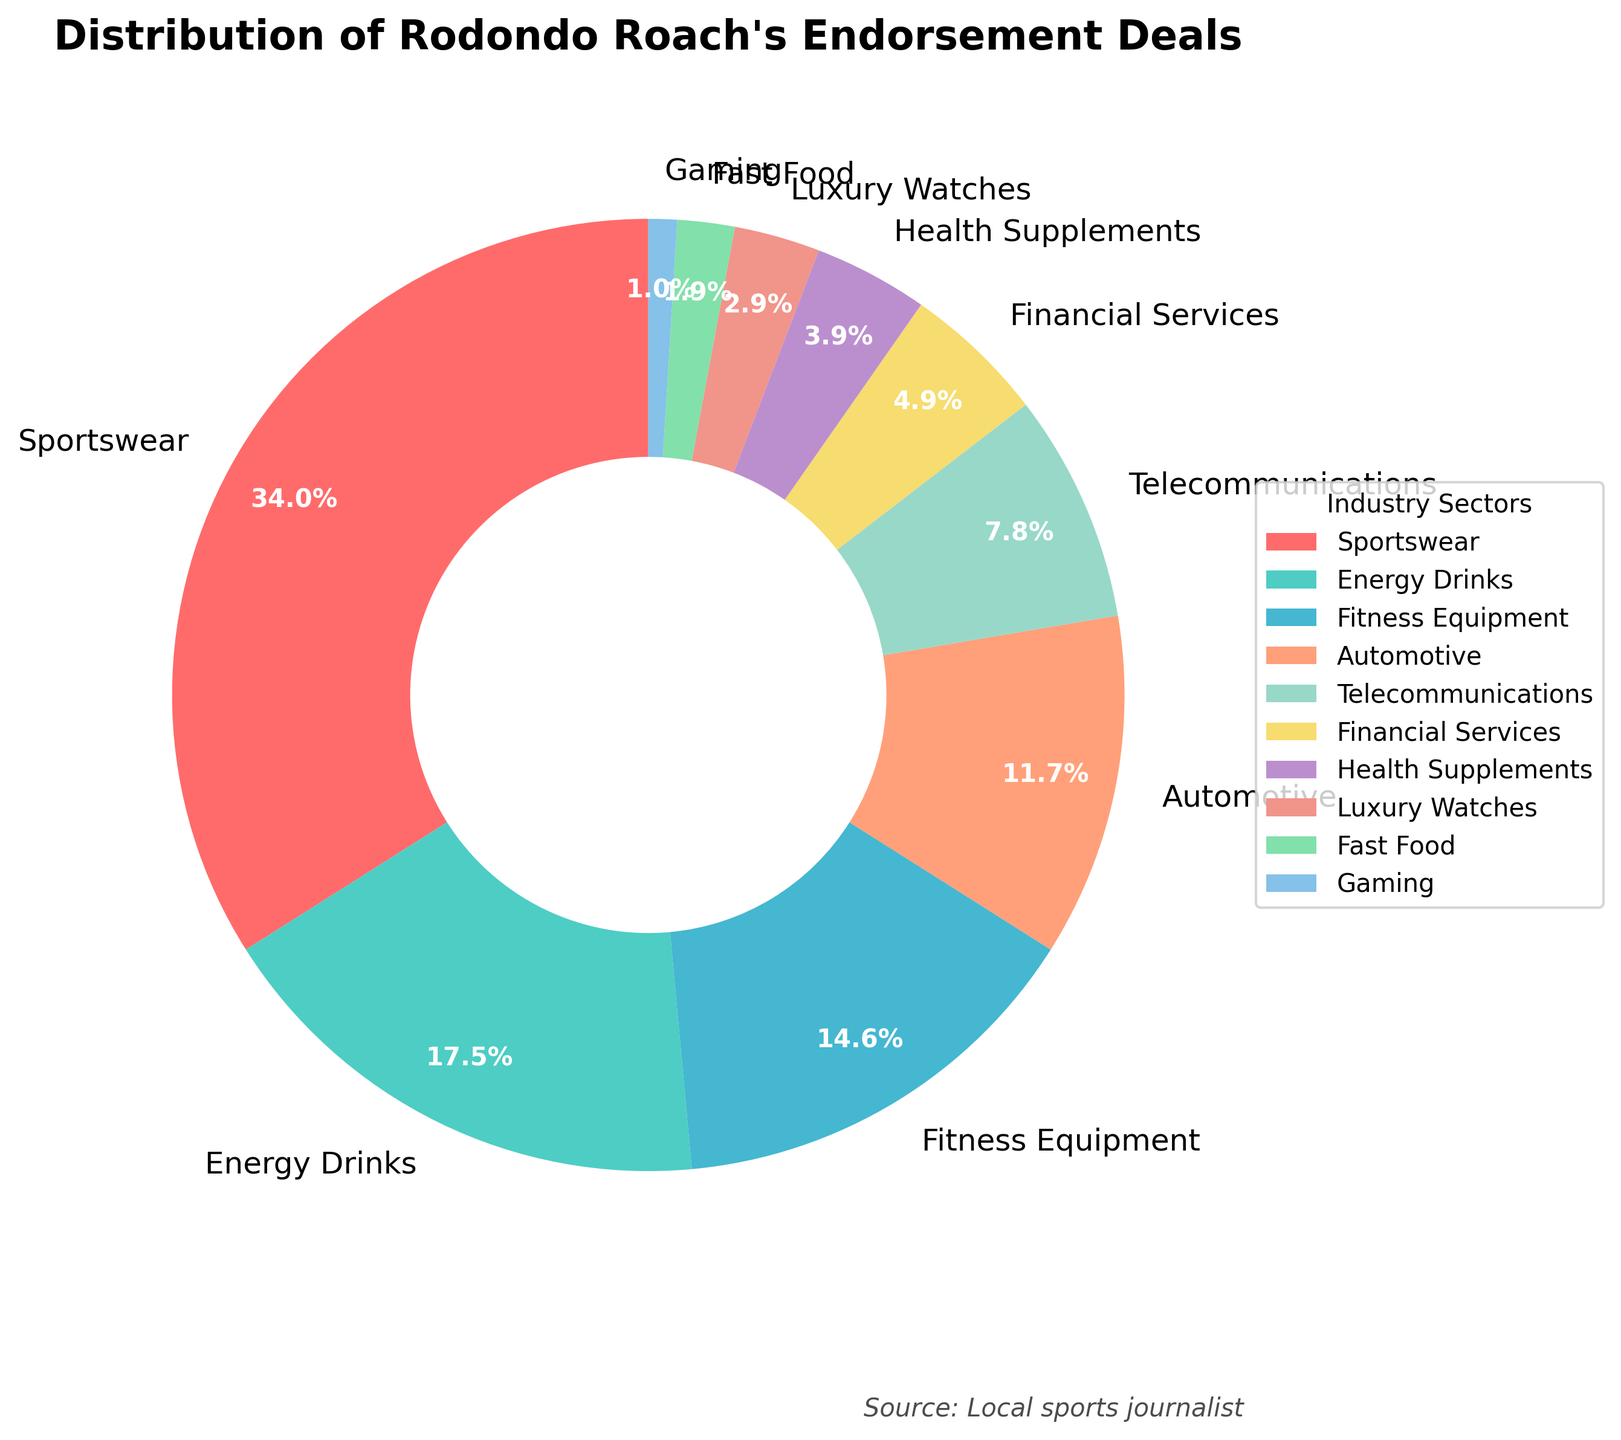Which industry has the highest percentage of Rodondo Roach's endorsement deals? To find the industry with the highest percentage, look at the segment representing each industry and identify which one takes up the largest portion of the pie chart. Here, the "Sportswear" segment appears the largest.
Answer: Sportswear What is the total percentage of endorsement deals in the Fitness Equipment and Automotive sectors combined? Add the percentages of the Fitness Equipment sector (15%) and the Automotive sector (12%) to get the total percentage. 15% + 12% = 27%.
Answer: 27% Which industries have endorsement deals that total less than 5% each? Identify the segments in the pie chart that represent industries with percentages less than 5%. The segments corresponding to "Health Supplements" (4%), "Luxury Watches" (3%), "Fast Food" (2%), and "Gaming" (1%) are each less than 5%.
Answer: Health Supplements, Luxury Watches, Fast Food, Gaming How does the percentage of endorsement deals in Telecommunications compare to that in Financial Services? Compare the percentage of the Telecommunications sector (8%) with the Financial Services sector (5%). 8% is greater than 5%.
Answer: Telecommunications > Financial Services What is the difference in the percentage of endorsement deals between the Sportswear and Energy Drinks sectors? Subtract the percentage of the Energy Drinks sector (18%) from the percentage of the Sportswear sector (35%). 35% - 18% = 17%.
Answer: 17% How much larger is the Sportswear sector compared to the Health Supplements sector? Calculate the difference by subtracting the percentage of Health Supplements (4%) from the percentage of Sportswear (35%). 35% - 4% = 31%.
Answer: 31% Which sector has the smallest percentage of endorsement deals, and what is that percentage? Identify the segment that represents the smallest portion of the pie chart. The "Gaming" sector is the smallest, with a percentage of 1%.
Answer: Gaming, 1% If you combine the Energy Drinks and Financial Services sectors, do they together exceed the percentage of the Fitness Equipment sector? Add the percentages of the Energy Drinks sector (18%) and the Financial Services sector (5%) and compare the sum to the Fitness Equipment sector (15%). 18% + 5% = 23%, which is greater than 15%.
Answer: Yes What are the visual attributes of the segments corresponding to the Energy Drinks and the Telecommunications sectors? Describe the colors that represent these sectors in the pie chart. The Energy Drinks sector is colored in a greenish-blue shade, and the Telecommunications sector is represented by a light blue shade.
Answer: Greenish-blue for Energy Drinks, light blue for Telecommunications 